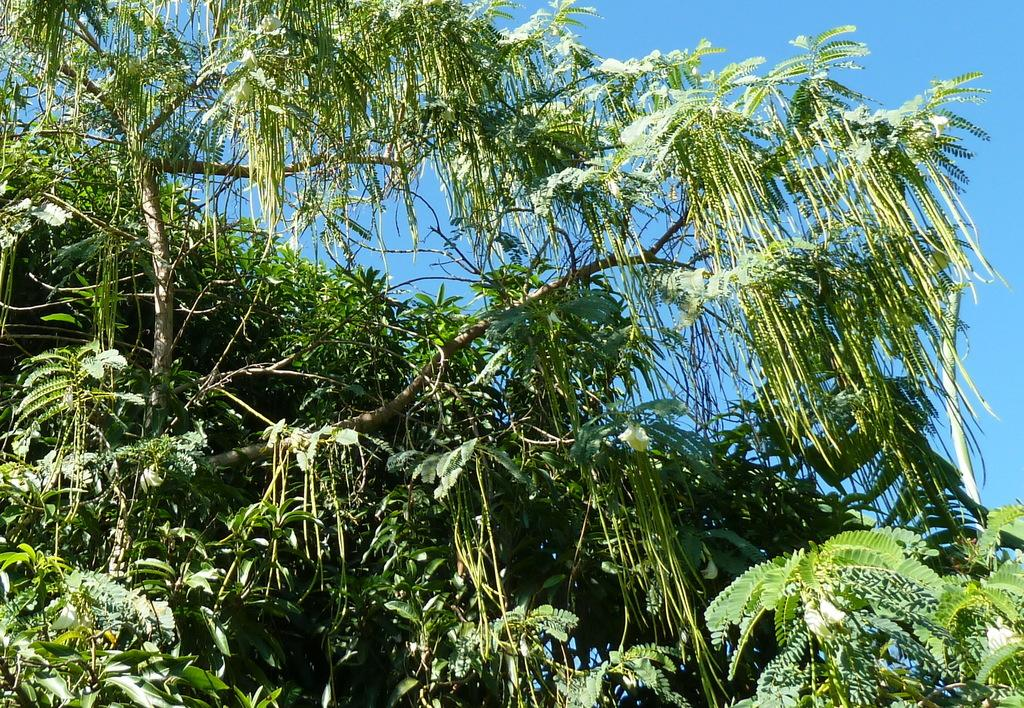What type of vegetation or plants can be seen in the image? There is greenery in the image, which suggests the presence of plants or vegetation. How many legs can be seen supporting the rail in the image? There is no rail or legs present in the image; it only features greenery. 